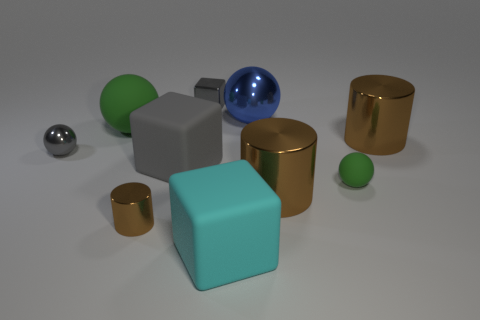Is the number of small green matte things that are to the left of the tiny cylinder less than the number of small balls that are to the left of the blue metallic ball?
Give a very brief answer. Yes. What number of other objects are the same size as the gray metal cube?
Your answer should be very brief. 3. Is the gray sphere made of the same material as the brown cylinder that is on the left side of the cyan matte block?
Make the answer very short. Yes. How many objects are cyan cubes that are on the right side of the small gray metallic cube or things in front of the gray ball?
Offer a very short reply. 5. The metal block is what color?
Your answer should be compact. Gray. Is the number of brown cylinders right of the tiny rubber thing less than the number of red metal cylinders?
Your answer should be compact. No. Are there any large purple balls?
Keep it short and to the point. No. Are there fewer gray balls than large brown metal cylinders?
Offer a terse response. Yes. How many small cylinders are made of the same material as the blue sphere?
Provide a succinct answer. 1. The tiny ball that is the same material as the large green object is what color?
Keep it short and to the point. Green. 